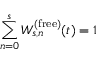Convert formula to latex. <formula><loc_0><loc_0><loc_500><loc_500>\sum _ { n = 0 } ^ { s } W _ { s , n } ^ { ( f r e e ) } ( t ) = 1</formula> 